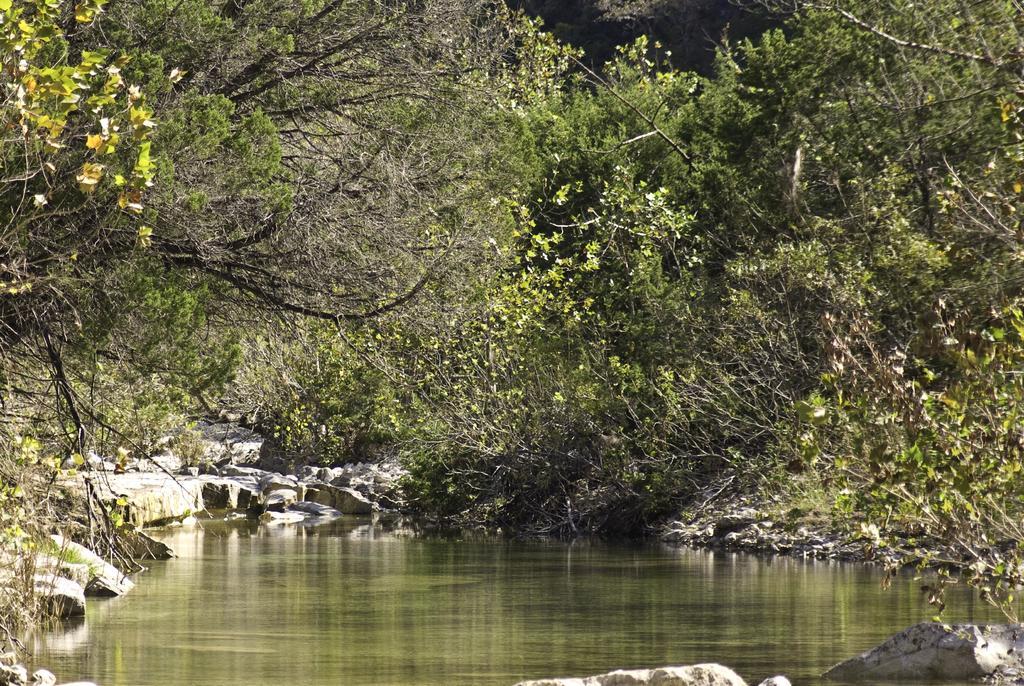Describe this image in one or two sentences. In this image we can see some rocks, water and trees. 